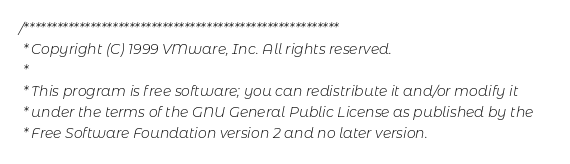<code> <loc_0><loc_0><loc_500><loc_500><_C_>/*********************************************************
 * Copyright (C) 1999 VMware, Inc. All rights reserved.
 *
 * This program is free software; you can redistribute it and/or modify it
 * under the terms of the GNU General Public License as published by the
 * Free Software Foundation version 2 and no later version.</code> 